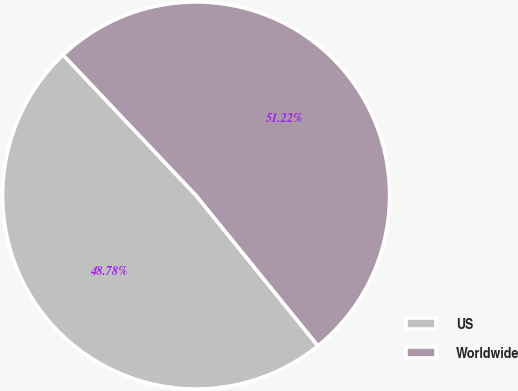<chart> <loc_0><loc_0><loc_500><loc_500><pie_chart><fcel>US<fcel>Worldwide<nl><fcel>48.78%<fcel>51.22%<nl></chart> 